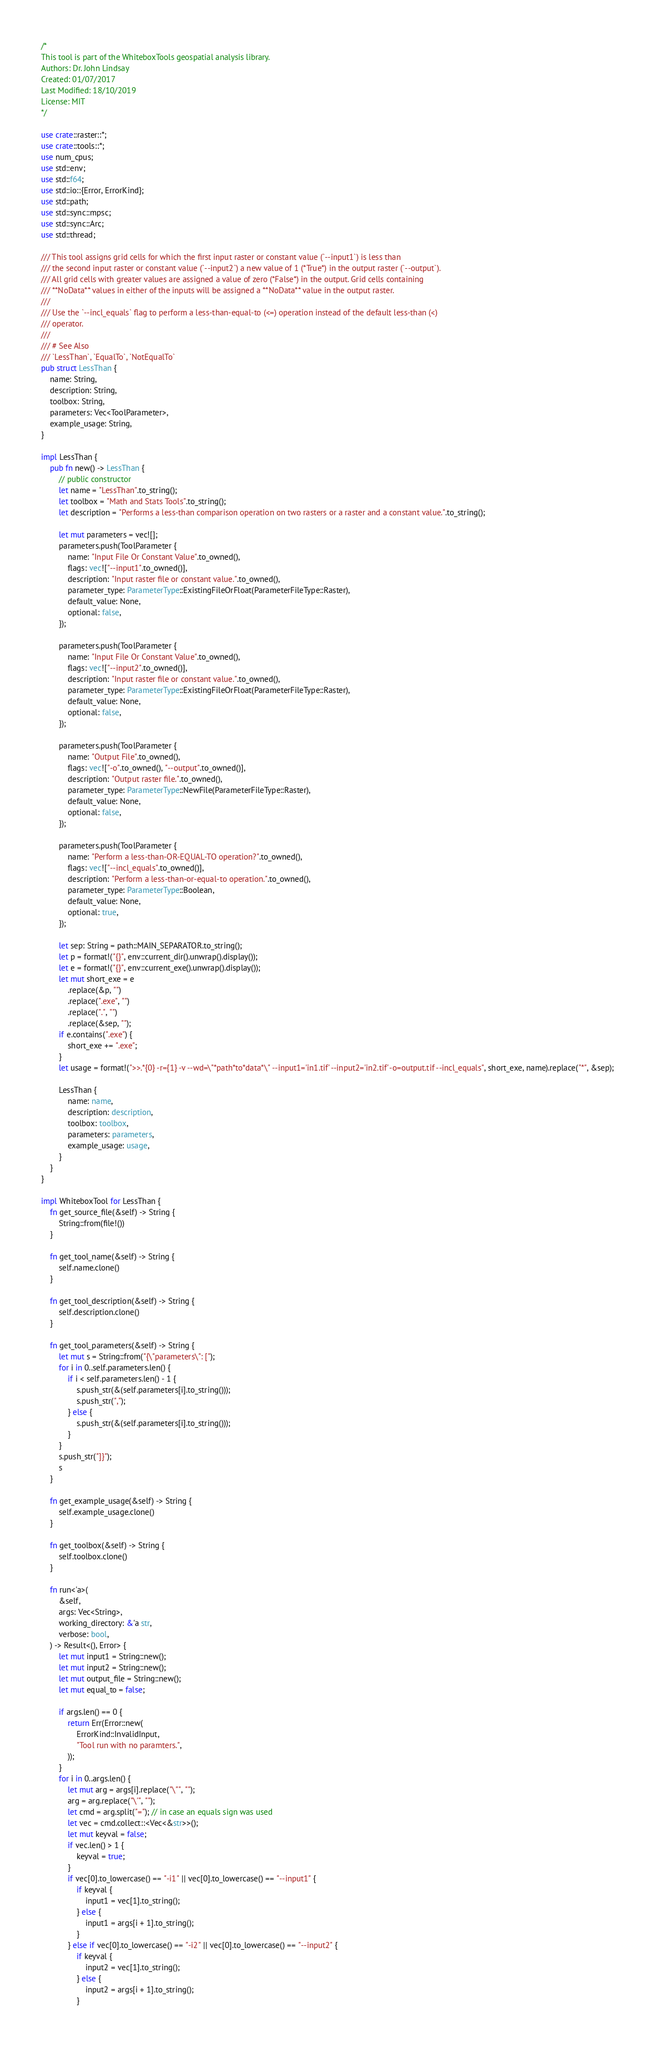<code> <loc_0><loc_0><loc_500><loc_500><_Rust_>/*
This tool is part of the WhiteboxTools geospatial analysis library.
Authors: Dr. John Lindsay
Created: 01/07/2017
Last Modified: 18/10/2019
License: MIT
*/

use crate::raster::*;
use crate::tools::*;
use num_cpus;
use std::env;
use std::f64;
use std::io::{Error, ErrorKind};
use std::path;
use std::sync::mpsc;
use std::sync::Arc;
use std::thread;

/// This tool assigns grid cells for which the first input raster or constant value (`--input1`) is less than
/// the second input raster or constant value (`--input2`) a new value of 1 (*True*) in the output raster (`--output`). 
/// All grid cells with greater values are assigned a value of zero (*False*) in the output. Grid cells containing 
/// **NoData** values in either of the inputs will be assigned a **NoData** value in the output raster.
/// 
/// Use the `--incl_equals` flag to perform a less-than-equal-to (<=) operation instead of the default less-than (<)
/// operator.
/// 
/// # See Also
/// `LessThan`, `EqualTo`, `NotEqualTo`
pub struct LessThan {
    name: String,
    description: String,
    toolbox: String,
    parameters: Vec<ToolParameter>,
    example_usage: String,
}

impl LessThan {
    pub fn new() -> LessThan {
        // public constructor
        let name = "LessThan".to_string();
        let toolbox = "Math and Stats Tools".to_string();
        let description = "Performs a less-than comparison operation on two rasters or a raster and a constant value.".to_string();

        let mut parameters = vec![];
        parameters.push(ToolParameter {
            name: "Input File Or Constant Value".to_owned(),
            flags: vec!["--input1".to_owned()],
            description: "Input raster file or constant value.".to_owned(),
            parameter_type: ParameterType::ExistingFileOrFloat(ParameterFileType::Raster),
            default_value: None,
            optional: false,
        });

        parameters.push(ToolParameter {
            name: "Input File Or Constant Value".to_owned(),
            flags: vec!["--input2".to_owned()],
            description: "Input raster file or constant value.".to_owned(),
            parameter_type: ParameterType::ExistingFileOrFloat(ParameterFileType::Raster),
            default_value: None,
            optional: false,
        });

        parameters.push(ToolParameter {
            name: "Output File".to_owned(),
            flags: vec!["-o".to_owned(), "--output".to_owned()],
            description: "Output raster file.".to_owned(),
            parameter_type: ParameterType::NewFile(ParameterFileType::Raster),
            default_value: None,
            optional: false,
        });

        parameters.push(ToolParameter {
            name: "Perform a less-than-OR-EQUAL-TO operation?".to_owned(),
            flags: vec!["--incl_equals".to_owned()],
            description: "Perform a less-than-or-equal-to operation.".to_owned(),
            parameter_type: ParameterType::Boolean,
            default_value: None,
            optional: true,
        });

        let sep: String = path::MAIN_SEPARATOR.to_string();
        let p = format!("{}", env::current_dir().unwrap().display());
        let e = format!("{}", env::current_exe().unwrap().display());
        let mut short_exe = e
            .replace(&p, "")
            .replace(".exe", "")
            .replace(".", "")
            .replace(&sep, "");
        if e.contains(".exe") {
            short_exe += ".exe";
        }
        let usage = format!(">>.*{0} -r={1} -v --wd=\"*path*to*data*\" --input1='in1.tif' --input2='in2.tif' -o=output.tif --incl_equals", short_exe, name).replace("*", &sep);

        LessThan {
            name: name,
            description: description,
            toolbox: toolbox,
            parameters: parameters,
            example_usage: usage,
        }
    }
}

impl WhiteboxTool for LessThan {
    fn get_source_file(&self) -> String {
        String::from(file!())
    }

    fn get_tool_name(&self) -> String {
        self.name.clone()
    }

    fn get_tool_description(&self) -> String {
        self.description.clone()
    }

    fn get_tool_parameters(&self) -> String {
        let mut s = String::from("{\"parameters\": [");
        for i in 0..self.parameters.len() {
            if i < self.parameters.len() - 1 {
                s.push_str(&(self.parameters[i].to_string()));
                s.push_str(",");
            } else {
                s.push_str(&(self.parameters[i].to_string()));
            }
        }
        s.push_str("]}");
        s
    }

    fn get_example_usage(&self) -> String {
        self.example_usage.clone()
    }

    fn get_toolbox(&self) -> String {
        self.toolbox.clone()
    }

    fn run<'a>(
        &self,
        args: Vec<String>,
        working_directory: &'a str,
        verbose: bool,
    ) -> Result<(), Error> {
        let mut input1 = String::new();
        let mut input2 = String::new();
        let mut output_file = String::new();
        let mut equal_to = false;

        if args.len() == 0 {
            return Err(Error::new(
                ErrorKind::InvalidInput,
                "Tool run with no paramters.",
            ));
        }
        for i in 0..args.len() {
            let mut arg = args[i].replace("\"", "");
            arg = arg.replace("\'", "");
            let cmd = arg.split("="); // in case an equals sign was used
            let vec = cmd.collect::<Vec<&str>>();
            let mut keyval = false;
            if vec.len() > 1 {
                keyval = true;
            }
            if vec[0].to_lowercase() == "-i1" || vec[0].to_lowercase() == "--input1" {
                if keyval {
                    input1 = vec[1].to_string();
                } else {
                    input1 = args[i + 1].to_string();
                }
            } else if vec[0].to_lowercase() == "-i2" || vec[0].to_lowercase() == "--input2" {
                if keyval {
                    input2 = vec[1].to_string();
                } else {
                    input2 = args[i + 1].to_string();
                }</code> 